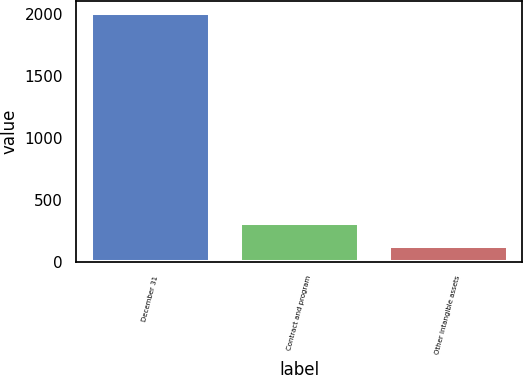Convert chart. <chart><loc_0><loc_0><loc_500><loc_500><bar_chart><fcel>December 31<fcel>Contract and program<fcel>Other intangible assets<nl><fcel>2004<fcel>317.4<fcel>130<nl></chart> 